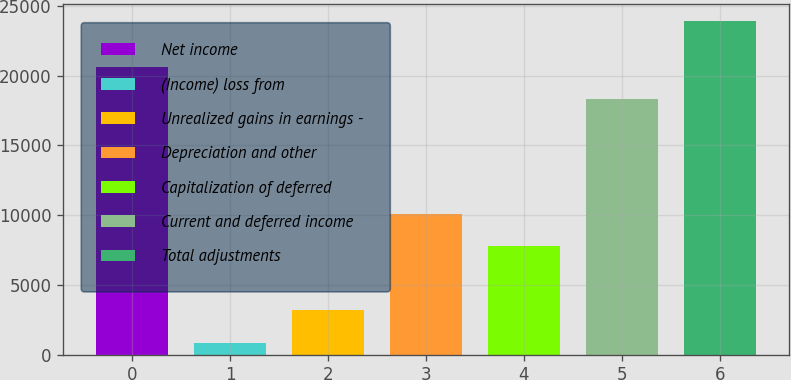Convert chart. <chart><loc_0><loc_0><loc_500><loc_500><bar_chart><fcel>Net income<fcel>(Income) loss from<fcel>Unrealized gains in earnings -<fcel>Depreciation and other<fcel>Capitalization of deferred<fcel>Current and deferred income<fcel>Total adjustments<nl><fcel>20637.6<fcel>858<fcel>3162.6<fcel>10100.6<fcel>7796<fcel>18333<fcel>23904<nl></chart> 